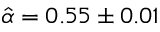<formula> <loc_0><loc_0><loc_500><loc_500>\hat { \alpha } = 0 . 5 5 \pm 0 . 0 1</formula> 